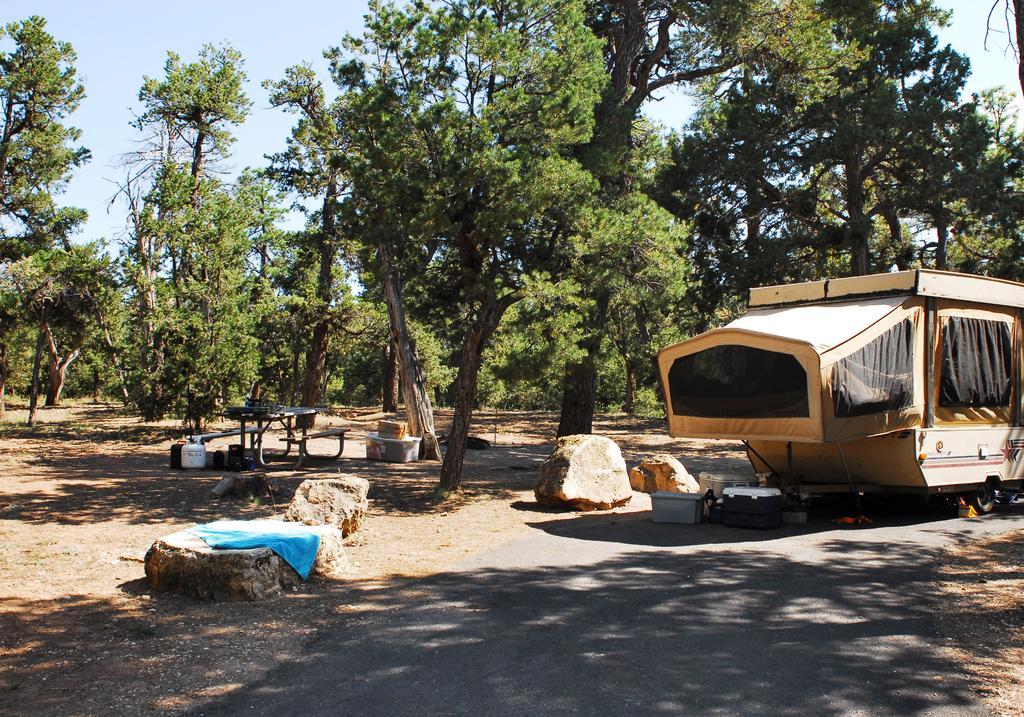What is the main subject of the image? There is a vehicle on the road in the image. What type of natural elements can be seen in the image? There are trees and rocks in the image. What type of man-made objects can be seen in the image? There is cloth, a container, and benches in the image. What is visible at the top of the image? The sky is visible at the top of the image. How many objects can be seen in the image? There are objects in the image, including the vehicle, trees, rocks, cloth, container, and benches. What time does the vehicle blow its horn in the image? There is no indication of the vehicle blowing its horn in the image, nor is there any information about the time. 